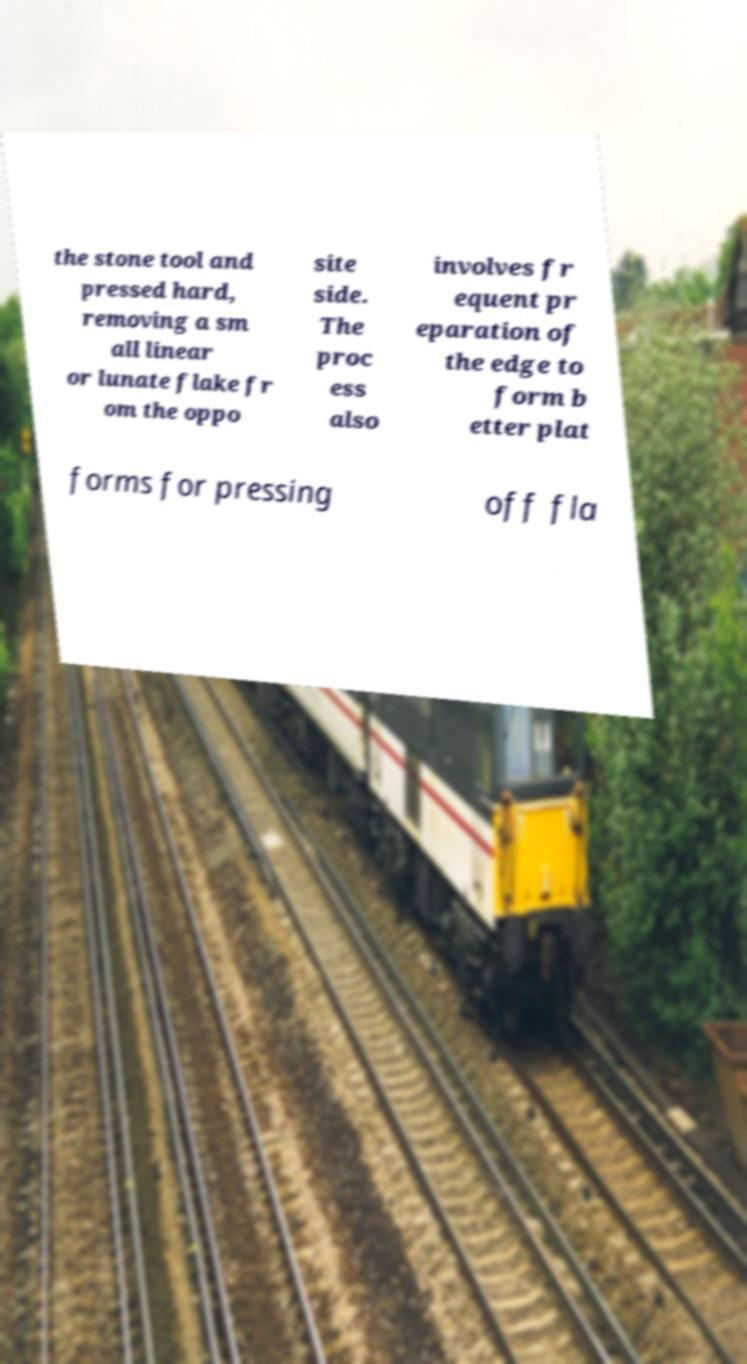Can you accurately transcribe the text from the provided image for me? the stone tool and pressed hard, removing a sm all linear or lunate flake fr om the oppo site side. The proc ess also involves fr equent pr eparation of the edge to form b etter plat forms for pressing off fla 